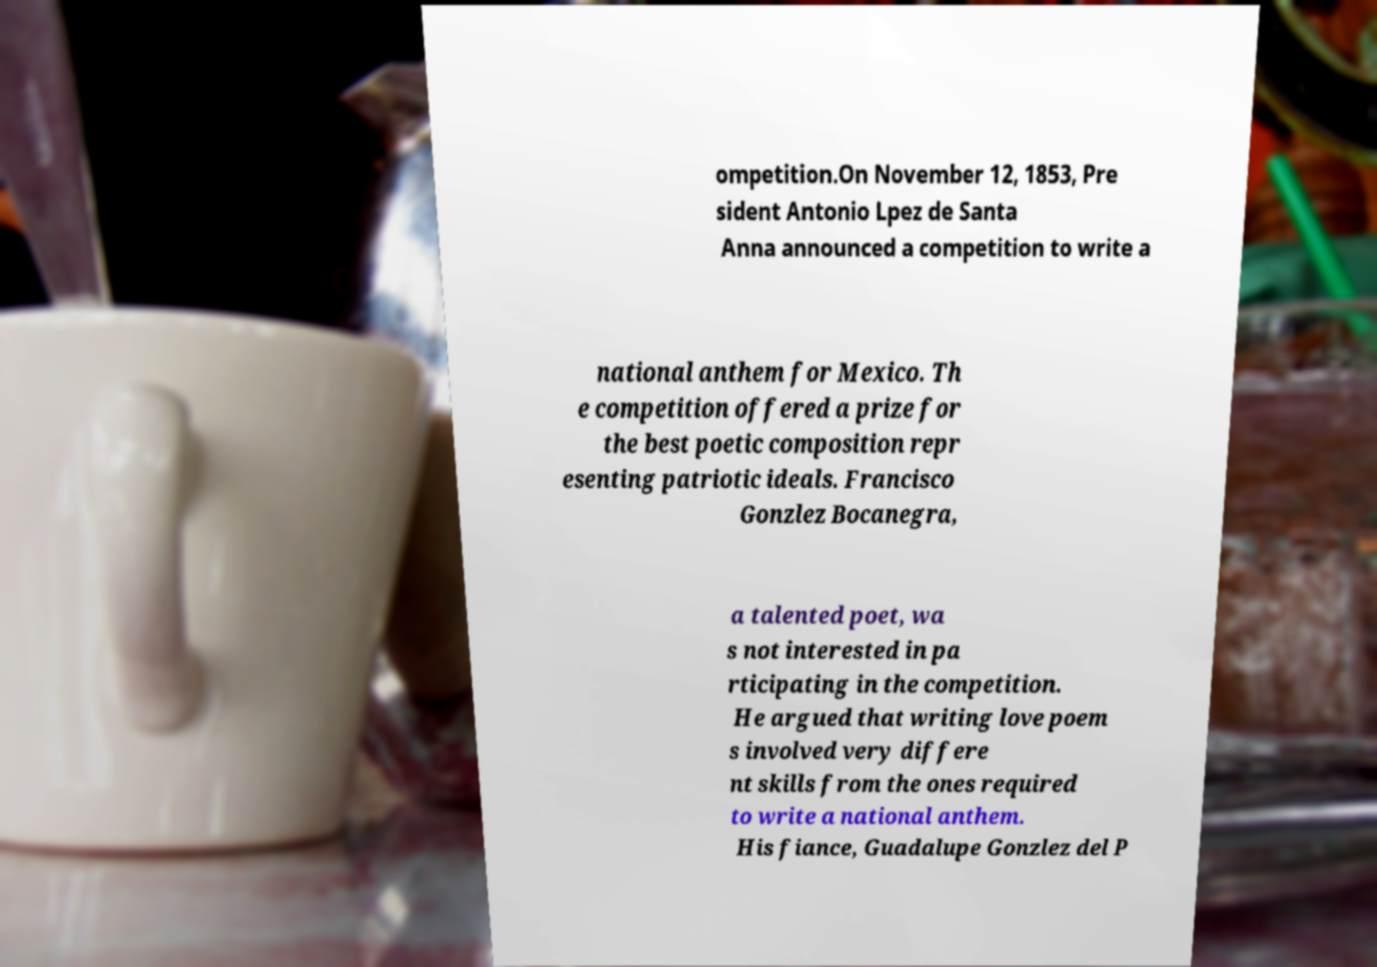Can you read and provide the text displayed in the image?This photo seems to have some interesting text. Can you extract and type it out for me? ompetition.On November 12, 1853, Pre sident Antonio Lpez de Santa Anna announced a competition to write a national anthem for Mexico. Th e competition offered a prize for the best poetic composition repr esenting patriotic ideals. Francisco Gonzlez Bocanegra, a talented poet, wa s not interested in pa rticipating in the competition. He argued that writing love poem s involved very differe nt skills from the ones required to write a national anthem. His fiance, Guadalupe Gonzlez del P 